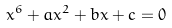<formula> <loc_0><loc_0><loc_500><loc_500>x ^ { 6 } + a x ^ { 2 } + b x + c = 0</formula> 